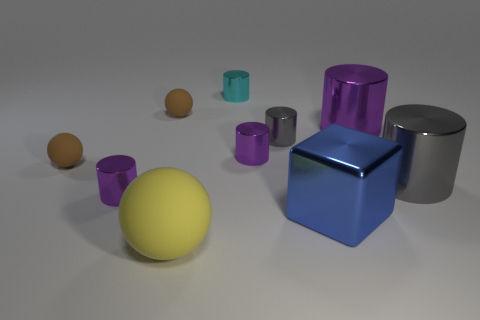What is the size of the cube that is the same material as the large gray cylinder?
Your answer should be very brief. Large. What number of other small matte things have the same shape as the yellow object?
Your response must be concise. 2. There is a brown matte object to the left of the small purple metallic cylinder that is left of the small cyan thing; what is its size?
Your response must be concise. Small. What is the material of the yellow thing that is the same size as the shiny block?
Give a very brief answer. Rubber. Are there any cubes that have the same material as the cyan thing?
Your response must be concise. Yes. The matte ball that is to the left of the small cylinder that is to the left of the matte thing in front of the blue shiny thing is what color?
Offer a very short reply. Brown. Is the color of the large cylinder on the left side of the big gray metallic cylinder the same as the shiny object that is left of the big matte ball?
Provide a succinct answer. Yes. Are there any other things of the same color as the block?
Provide a succinct answer. No. Is the number of small cyan shiny objects in front of the small gray metal cylinder less than the number of large brown cylinders?
Your answer should be very brief. No. How many brown matte things are there?
Offer a terse response. 2. 